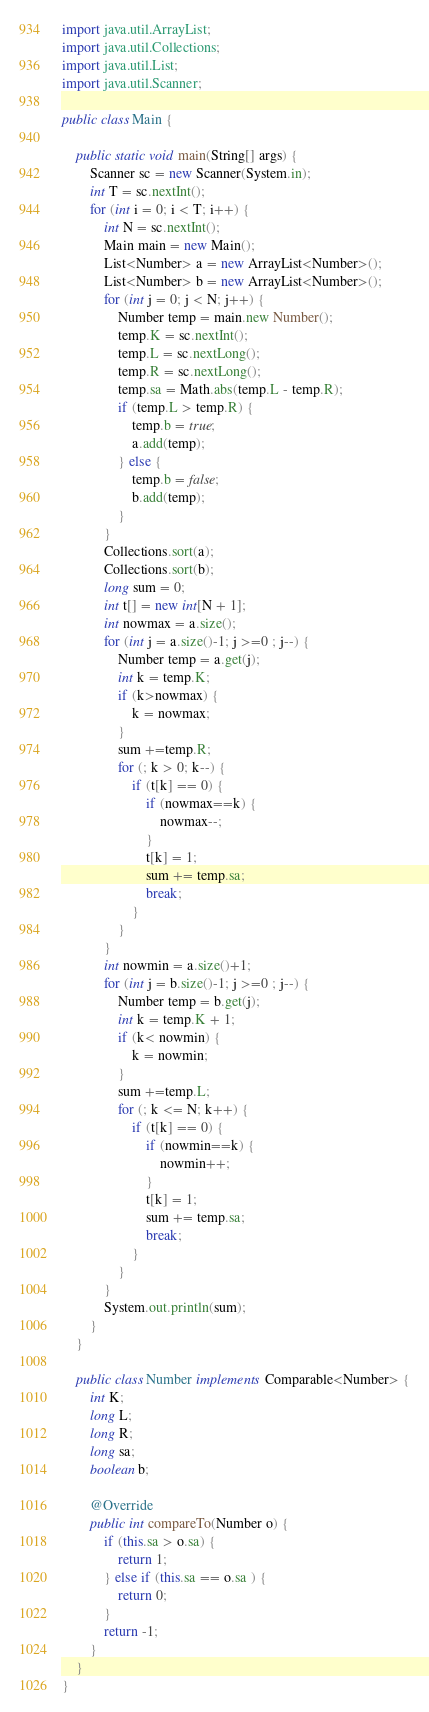<code> <loc_0><loc_0><loc_500><loc_500><_Java_>import java.util.ArrayList;
import java.util.Collections;
import java.util.List;
import java.util.Scanner;

public class Main {

	public static void main(String[] args) {
		Scanner sc = new Scanner(System.in);
		int T = sc.nextInt();
		for (int i = 0; i < T; i++) {
			int N = sc.nextInt();
			Main main = new Main();
			List<Number> a = new ArrayList<Number>();
			List<Number> b = new ArrayList<Number>();
			for (int j = 0; j < N; j++) {
				Number temp = main.new Number();
				temp.K = sc.nextInt();
				temp.L = sc.nextLong();
				temp.R = sc.nextLong();
				temp.sa = Math.abs(temp.L - temp.R);
				if (temp.L > temp.R) {
					temp.b = true;
					a.add(temp);
				} else {
					temp.b = false;
					b.add(temp);
				}
			}
			Collections.sort(a);
			Collections.sort(b);
			long sum = 0;
			int t[] = new int[N + 1];
			int nowmax = a.size();
			for (int j = a.size()-1; j >=0 ; j--) {
				Number temp = a.get(j);
				int k = temp.K;
				if (k>nowmax) {
					k = nowmax;
				}
				sum +=temp.R;
				for (; k > 0; k--) {
					if (t[k] == 0) {
						if (nowmax==k) {
							nowmax--;
						}
						t[k] = 1;
						sum += temp.sa;
						break;
					}
				}
			}
			int nowmin = a.size()+1;
			for (int j = b.size()-1; j >=0 ; j--) {
				Number temp = b.get(j);
				int k = temp.K + 1;
				if (k< nowmin) {
					k = nowmin;
				}
				sum +=temp.L;
				for (; k <= N; k++) {
					if (t[k] == 0) {
						if (nowmin==k) {
							nowmin++;
						}
						t[k] = 1;
						sum += temp.sa;
						break;
					}
				}
			}
			System.out.println(sum);
		}
	}

	public class Number implements Comparable<Number> {
		int K;
		long L;
		long R;
		long sa;
		boolean b;

		@Override
		public int compareTo(Number o) {
			if (this.sa > o.sa) {
				return 1;
			} else if (this.sa == o.sa ) {
				return 0;
			}
			return -1;
		}
	}
}</code> 